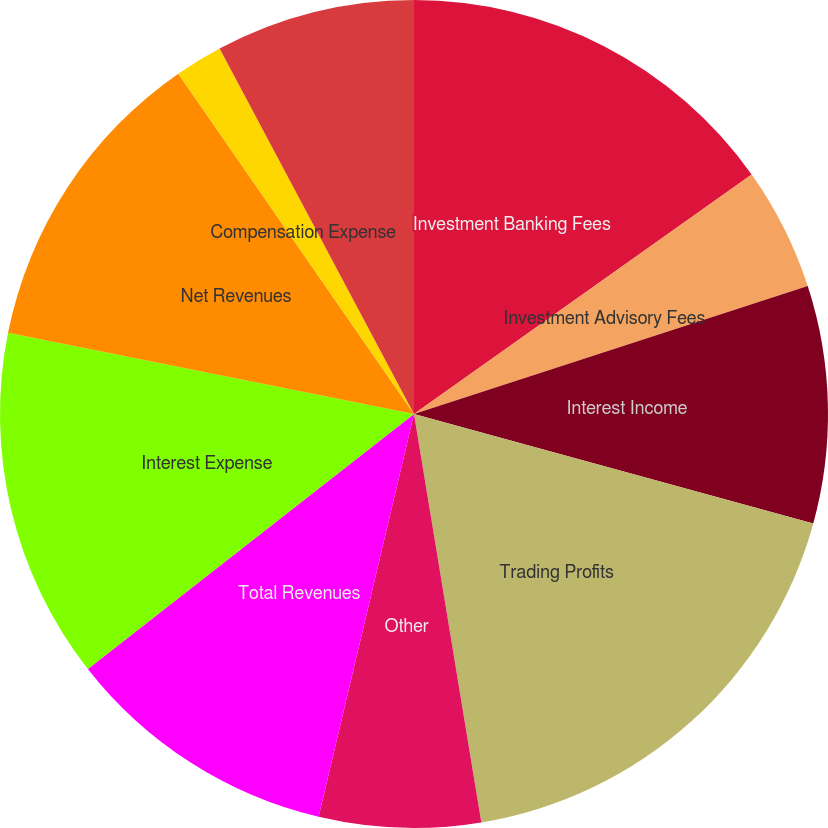Convert chart. <chart><loc_0><loc_0><loc_500><loc_500><pie_chart><fcel>Investment Banking Fees<fcel>Investment Advisory Fees<fcel>Interest Income<fcel>Trading Profits<fcel>Other<fcel>Total Revenues<fcel>Interest Expense<fcel>Net Revenues<fcel>Compensation Expense<fcel>Other Expense<nl><fcel>15.18%<fcel>4.82%<fcel>9.26%<fcel>18.14%<fcel>6.3%<fcel>10.74%<fcel>13.7%<fcel>12.22%<fcel>1.86%<fcel>7.78%<nl></chart> 